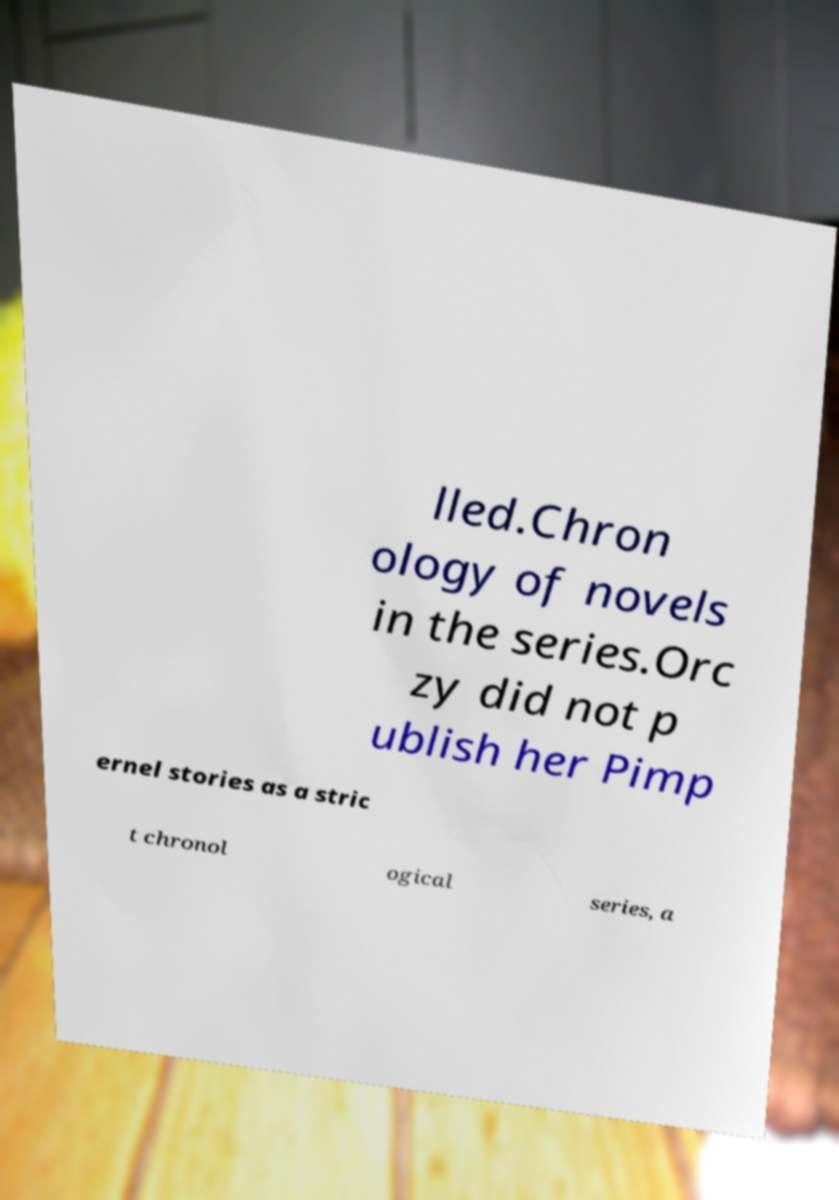Could you extract and type out the text from this image? lled.Chron ology of novels in the series.Orc zy did not p ublish her Pimp ernel stories as a stric t chronol ogical series, a 